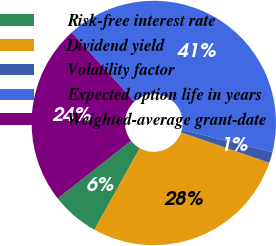Convert chart. <chart><loc_0><loc_0><loc_500><loc_500><pie_chart><fcel>Risk-free interest rate<fcel>Dividend yield<fcel>Volatility factor<fcel>Expected option life in years<fcel>Weighted-average grant-date<nl><fcel>6.33%<fcel>27.8%<fcel>1.46%<fcel>40.53%<fcel>23.88%<nl></chart> 